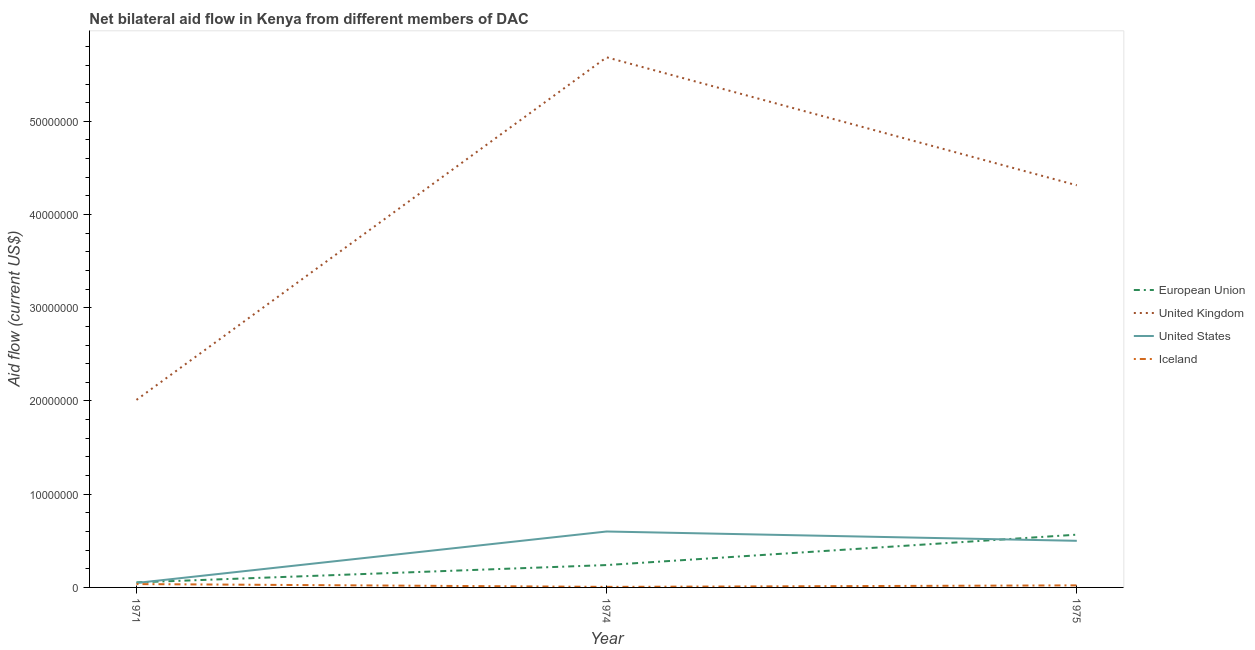Is the number of lines equal to the number of legend labels?
Your answer should be very brief. Yes. What is the amount of aid given by uk in 1975?
Give a very brief answer. 4.31e+07. Across all years, what is the maximum amount of aid given by eu?
Provide a succinct answer. 5.66e+06. Across all years, what is the minimum amount of aid given by eu?
Provide a short and direct response. 5.40e+05. In which year was the amount of aid given by us maximum?
Provide a succinct answer. 1974. In which year was the amount of aid given by iceland minimum?
Ensure brevity in your answer.  1974. What is the total amount of aid given by iceland in the graph?
Give a very brief answer. 6.40e+05. What is the difference between the amount of aid given by us in 1974 and that in 1975?
Give a very brief answer. 1.00e+06. What is the difference between the amount of aid given by iceland in 1971 and the amount of aid given by us in 1974?
Offer a terse response. -5.64e+06. What is the average amount of aid given by us per year?
Your answer should be compact. 3.83e+06. In the year 1971, what is the difference between the amount of aid given by eu and amount of aid given by us?
Offer a terse response. 6.00e+04. What is the ratio of the amount of aid given by us in 1971 to that in 1974?
Offer a terse response. 0.08. Is the difference between the amount of aid given by uk in 1971 and 1975 greater than the difference between the amount of aid given by us in 1971 and 1975?
Provide a succinct answer. No. What is the difference between the highest and the second highest amount of aid given by iceland?
Ensure brevity in your answer.  1.40e+05. What is the difference between the highest and the lowest amount of aid given by eu?
Keep it short and to the point. 5.12e+06. In how many years, is the amount of aid given by eu greater than the average amount of aid given by eu taken over all years?
Keep it short and to the point. 1. Is it the case that in every year, the sum of the amount of aid given by eu and amount of aid given by uk is greater than the amount of aid given by us?
Provide a short and direct response. Yes. Is the amount of aid given by uk strictly greater than the amount of aid given by eu over the years?
Your answer should be compact. Yes. How many lines are there?
Ensure brevity in your answer.  4. What is the difference between two consecutive major ticks on the Y-axis?
Your answer should be compact. 1.00e+07. Does the graph contain any zero values?
Give a very brief answer. No. Does the graph contain grids?
Provide a succinct answer. No. How many legend labels are there?
Your answer should be very brief. 4. What is the title of the graph?
Your answer should be very brief. Net bilateral aid flow in Kenya from different members of DAC. Does "Interest Payments" appear as one of the legend labels in the graph?
Your answer should be compact. No. What is the label or title of the X-axis?
Your answer should be compact. Year. What is the label or title of the Y-axis?
Your answer should be compact. Aid flow (current US$). What is the Aid flow (current US$) in European Union in 1971?
Offer a terse response. 5.40e+05. What is the Aid flow (current US$) in United Kingdom in 1971?
Keep it short and to the point. 2.01e+07. What is the Aid flow (current US$) of European Union in 1974?
Your response must be concise. 2.40e+06. What is the Aid flow (current US$) in United Kingdom in 1974?
Offer a terse response. 5.69e+07. What is the Aid flow (current US$) in United States in 1974?
Your answer should be very brief. 6.00e+06. What is the Aid flow (current US$) of Iceland in 1974?
Provide a succinct answer. 6.00e+04. What is the Aid flow (current US$) of European Union in 1975?
Provide a succinct answer. 5.66e+06. What is the Aid flow (current US$) in United Kingdom in 1975?
Your answer should be compact. 4.31e+07. What is the Aid flow (current US$) in Iceland in 1975?
Offer a terse response. 2.20e+05. Across all years, what is the maximum Aid flow (current US$) of European Union?
Make the answer very short. 5.66e+06. Across all years, what is the maximum Aid flow (current US$) in United Kingdom?
Provide a succinct answer. 5.69e+07. Across all years, what is the maximum Aid flow (current US$) in Iceland?
Give a very brief answer. 3.60e+05. Across all years, what is the minimum Aid flow (current US$) in European Union?
Your answer should be compact. 5.40e+05. Across all years, what is the minimum Aid flow (current US$) of United Kingdom?
Keep it short and to the point. 2.01e+07. Across all years, what is the minimum Aid flow (current US$) in United States?
Keep it short and to the point. 4.80e+05. What is the total Aid flow (current US$) of European Union in the graph?
Offer a very short reply. 8.60e+06. What is the total Aid flow (current US$) in United Kingdom in the graph?
Your response must be concise. 1.20e+08. What is the total Aid flow (current US$) in United States in the graph?
Your response must be concise. 1.15e+07. What is the total Aid flow (current US$) in Iceland in the graph?
Your response must be concise. 6.40e+05. What is the difference between the Aid flow (current US$) of European Union in 1971 and that in 1974?
Provide a short and direct response. -1.86e+06. What is the difference between the Aid flow (current US$) of United Kingdom in 1971 and that in 1974?
Your response must be concise. -3.68e+07. What is the difference between the Aid flow (current US$) of United States in 1971 and that in 1974?
Keep it short and to the point. -5.52e+06. What is the difference between the Aid flow (current US$) in European Union in 1971 and that in 1975?
Make the answer very short. -5.12e+06. What is the difference between the Aid flow (current US$) in United Kingdom in 1971 and that in 1975?
Make the answer very short. -2.30e+07. What is the difference between the Aid flow (current US$) of United States in 1971 and that in 1975?
Provide a succinct answer. -4.52e+06. What is the difference between the Aid flow (current US$) in European Union in 1974 and that in 1975?
Provide a succinct answer. -3.26e+06. What is the difference between the Aid flow (current US$) in United Kingdom in 1974 and that in 1975?
Provide a succinct answer. 1.37e+07. What is the difference between the Aid flow (current US$) of United States in 1974 and that in 1975?
Your answer should be very brief. 1.00e+06. What is the difference between the Aid flow (current US$) of European Union in 1971 and the Aid flow (current US$) of United Kingdom in 1974?
Give a very brief answer. -5.63e+07. What is the difference between the Aid flow (current US$) in European Union in 1971 and the Aid flow (current US$) in United States in 1974?
Ensure brevity in your answer.  -5.46e+06. What is the difference between the Aid flow (current US$) of European Union in 1971 and the Aid flow (current US$) of Iceland in 1974?
Give a very brief answer. 4.80e+05. What is the difference between the Aid flow (current US$) in United Kingdom in 1971 and the Aid flow (current US$) in United States in 1974?
Offer a very short reply. 1.41e+07. What is the difference between the Aid flow (current US$) of United Kingdom in 1971 and the Aid flow (current US$) of Iceland in 1974?
Provide a succinct answer. 2.01e+07. What is the difference between the Aid flow (current US$) of European Union in 1971 and the Aid flow (current US$) of United Kingdom in 1975?
Provide a succinct answer. -4.26e+07. What is the difference between the Aid flow (current US$) of European Union in 1971 and the Aid flow (current US$) of United States in 1975?
Provide a succinct answer. -4.46e+06. What is the difference between the Aid flow (current US$) of United Kingdom in 1971 and the Aid flow (current US$) of United States in 1975?
Your response must be concise. 1.51e+07. What is the difference between the Aid flow (current US$) in United Kingdom in 1971 and the Aid flow (current US$) in Iceland in 1975?
Give a very brief answer. 1.99e+07. What is the difference between the Aid flow (current US$) of United States in 1971 and the Aid flow (current US$) of Iceland in 1975?
Your answer should be compact. 2.60e+05. What is the difference between the Aid flow (current US$) of European Union in 1974 and the Aid flow (current US$) of United Kingdom in 1975?
Give a very brief answer. -4.07e+07. What is the difference between the Aid flow (current US$) in European Union in 1974 and the Aid flow (current US$) in United States in 1975?
Make the answer very short. -2.60e+06. What is the difference between the Aid flow (current US$) of European Union in 1974 and the Aid flow (current US$) of Iceland in 1975?
Your answer should be very brief. 2.18e+06. What is the difference between the Aid flow (current US$) in United Kingdom in 1974 and the Aid flow (current US$) in United States in 1975?
Offer a terse response. 5.19e+07. What is the difference between the Aid flow (current US$) in United Kingdom in 1974 and the Aid flow (current US$) in Iceland in 1975?
Your answer should be compact. 5.66e+07. What is the difference between the Aid flow (current US$) in United States in 1974 and the Aid flow (current US$) in Iceland in 1975?
Your response must be concise. 5.78e+06. What is the average Aid flow (current US$) in European Union per year?
Provide a succinct answer. 2.87e+06. What is the average Aid flow (current US$) in United Kingdom per year?
Offer a terse response. 4.00e+07. What is the average Aid flow (current US$) in United States per year?
Your response must be concise. 3.83e+06. What is the average Aid flow (current US$) in Iceland per year?
Offer a very short reply. 2.13e+05. In the year 1971, what is the difference between the Aid flow (current US$) of European Union and Aid flow (current US$) of United Kingdom?
Give a very brief answer. -1.96e+07. In the year 1971, what is the difference between the Aid flow (current US$) in United Kingdom and Aid flow (current US$) in United States?
Provide a short and direct response. 1.96e+07. In the year 1971, what is the difference between the Aid flow (current US$) of United Kingdom and Aid flow (current US$) of Iceland?
Ensure brevity in your answer.  1.98e+07. In the year 1974, what is the difference between the Aid flow (current US$) in European Union and Aid flow (current US$) in United Kingdom?
Make the answer very short. -5.45e+07. In the year 1974, what is the difference between the Aid flow (current US$) of European Union and Aid flow (current US$) of United States?
Provide a short and direct response. -3.60e+06. In the year 1974, what is the difference between the Aid flow (current US$) in European Union and Aid flow (current US$) in Iceland?
Ensure brevity in your answer.  2.34e+06. In the year 1974, what is the difference between the Aid flow (current US$) in United Kingdom and Aid flow (current US$) in United States?
Your answer should be very brief. 5.09e+07. In the year 1974, what is the difference between the Aid flow (current US$) of United Kingdom and Aid flow (current US$) of Iceland?
Your answer should be compact. 5.68e+07. In the year 1974, what is the difference between the Aid flow (current US$) of United States and Aid flow (current US$) of Iceland?
Give a very brief answer. 5.94e+06. In the year 1975, what is the difference between the Aid flow (current US$) of European Union and Aid flow (current US$) of United Kingdom?
Make the answer very short. -3.75e+07. In the year 1975, what is the difference between the Aid flow (current US$) in European Union and Aid flow (current US$) in Iceland?
Provide a succinct answer. 5.44e+06. In the year 1975, what is the difference between the Aid flow (current US$) of United Kingdom and Aid flow (current US$) of United States?
Ensure brevity in your answer.  3.81e+07. In the year 1975, what is the difference between the Aid flow (current US$) of United Kingdom and Aid flow (current US$) of Iceland?
Give a very brief answer. 4.29e+07. In the year 1975, what is the difference between the Aid flow (current US$) of United States and Aid flow (current US$) of Iceland?
Give a very brief answer. 4.78e+06. What is the ratio of the Aid flow (current US$) in European Union in 1971 to that in 1974?
Ensure brevity in your answer.  0.23. What is the ratio of the Aid flow (current US$) in United Kingdom in 1971 to that in 1974?
Your answer should be very brief. 0.35. What is the ratio of the Aid flow (current US$) in Iceland in 1971 to that in 1974?
Make the answer very short. 6. What is the ratio of the Aid flow (current US$) of European Union in 1971 to that in 1975?
Ensure brevity in your answer.  0.1. What is the ratio of the Aid flow (current US$) of United Kingdom in 1971 to that in 1975?
Give a very brief answer. 0.47. What is the ratio of the Aid flow (current US$) of United States in 1971 to that in 1975?
Keep it short and to the point. 0.1. What is the ratio of the Aid flow (current US$) in Iceland in 1971 to that in 1975?
Provide a short and direct response. 1.64. What is the ratio of the Aid flow (current US$) of European Union in 1974 to that in 1975?
Ensure brevity in your answer.  0.42. What is the ratio of the Aid flow (current US$) in United Kingdom in 1974 to that in 1975?
Give a very brief answer. 1.32. What is the ratio of the Aid flow (current US$) of United States in 1974 to that in 1975?
Offer a terse response. 1.2. What is the ratio of the Aid flow (current US$) in Iceland in 1974 to that in 1975?
Your response must be concise. 0.27. What is the difference between the highest and the second highest Aid flow (current US$) of European Union?
Your answer should be compact. 3.26e+06. What is the difference between the highest and the second highest Aid flow (current US$) of United Kingdom?
Keep it short and to the point. 1.37e+07. What is the difference between the highest and the second highest Aid flow (current US$) in United States?
Keep it short and to the point. 1.00e+06. What is the difference between the highest and the second highest Aid flow (current US$) of Iceland?
Give a very brief answer. 1.40e+05. What is the difference between the highest and the lowest Aid flow (current US$) of European Union?
Keep it short and to the point. 5.12e+06. What is the difference between the highest and the lowest Aid flow (current US$) in United Kingdom?
Give a very brief answer. 3.68e+07. What is the difference between the highest and the lowest Aid flow (current US$) of United States?
Your response must be concise. 5.52e+06. 